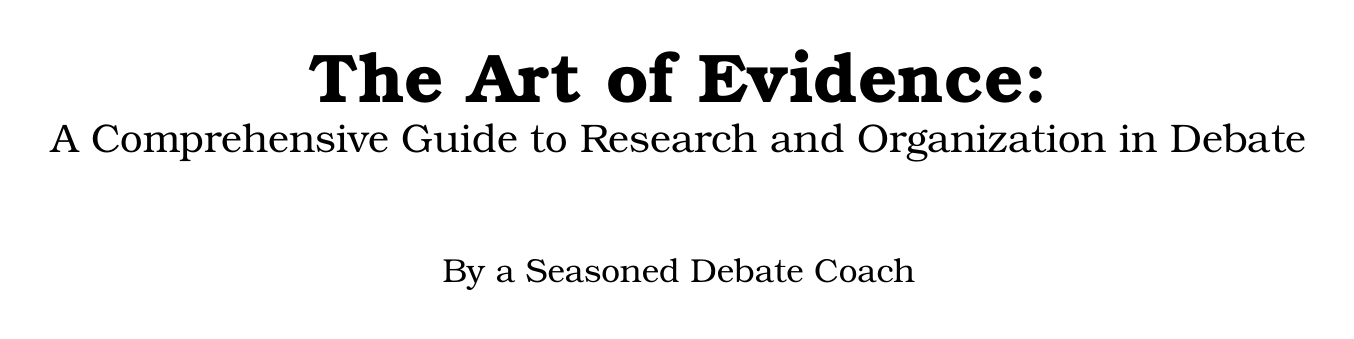what is the title of the manual? The title is the main heading that presents the subject of the document, which is "The Art of Evidence: A Comprehensive Guide to Research and Organization in Debate."
Answer: The Art of Evidence: A Comprehensive Guide to Research and Organization in Debate how many chapters are in the manual? The total number of chapters can be counted from the table of contents and includes all listed chapters, which is seven.
Answer: seven what method is suggested for structuring evidence within arguments? This refers to a specific technique described in the manual aimed at integrating evidence logically into arguments, which is the AREQ method.
Answer: AREQ what is one criterion for evaluating source reliability? This is one of several factors mentioned for assessing sources, highlighting the importance of author expertise.
Answer: author expertise what citation styles are covered for written citations? This lists the specific formats that are discussed in the context of debate briefs, which are APA, MLA, and Chicago styles.
Answer: APA, MLA, and Chicago what does Appendix C provide? This appendix contains definitions relevant to the document and is specifically focused on clarifying terminology for the users.
Answer: Glossary of Research and Citation Terms what is the primary focus of the chapter titled "Ethical Considerations in Evidence Use"? This chapter addresses specific ethical dilemmas related to the use of evidence in debate, particularly avoiding misrepresentation.
Answer: avoiding misrepresentation and out-of-context quotations who is the author of the manual? The author is identified as a seasoned debate coach, which indicates the expertise behind the document.
Answer: A seasoned debate coach 